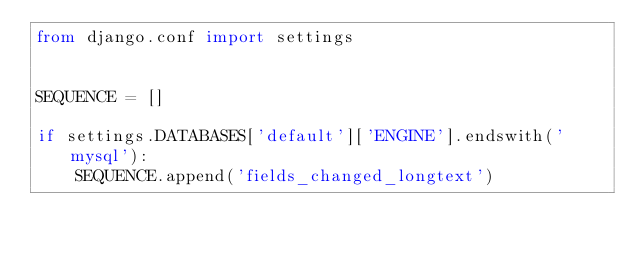<code> <loc_0><loc_0><loc_500><loc_500><_Python_>from django.conf import settings


SEQUENCE = []

if settings.DATABASES['default']['ENGINE'].endswith('mysql'):
    SEQUENCE.append('fields_changed_longtext')
</code> 